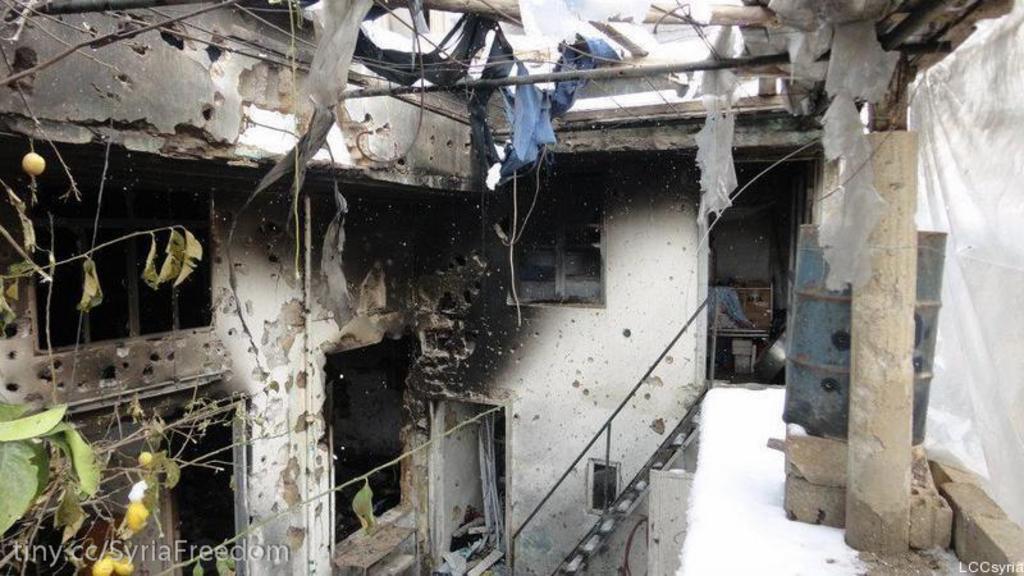How would you summarize this image in a sentence or two? In this picture I can see an inner view of a house. On the left side I can see stairs, a drum, white color cloth and other objects. On the right side I can see a wall, windows, plant and other objects. Here I can see poles and some objects. 